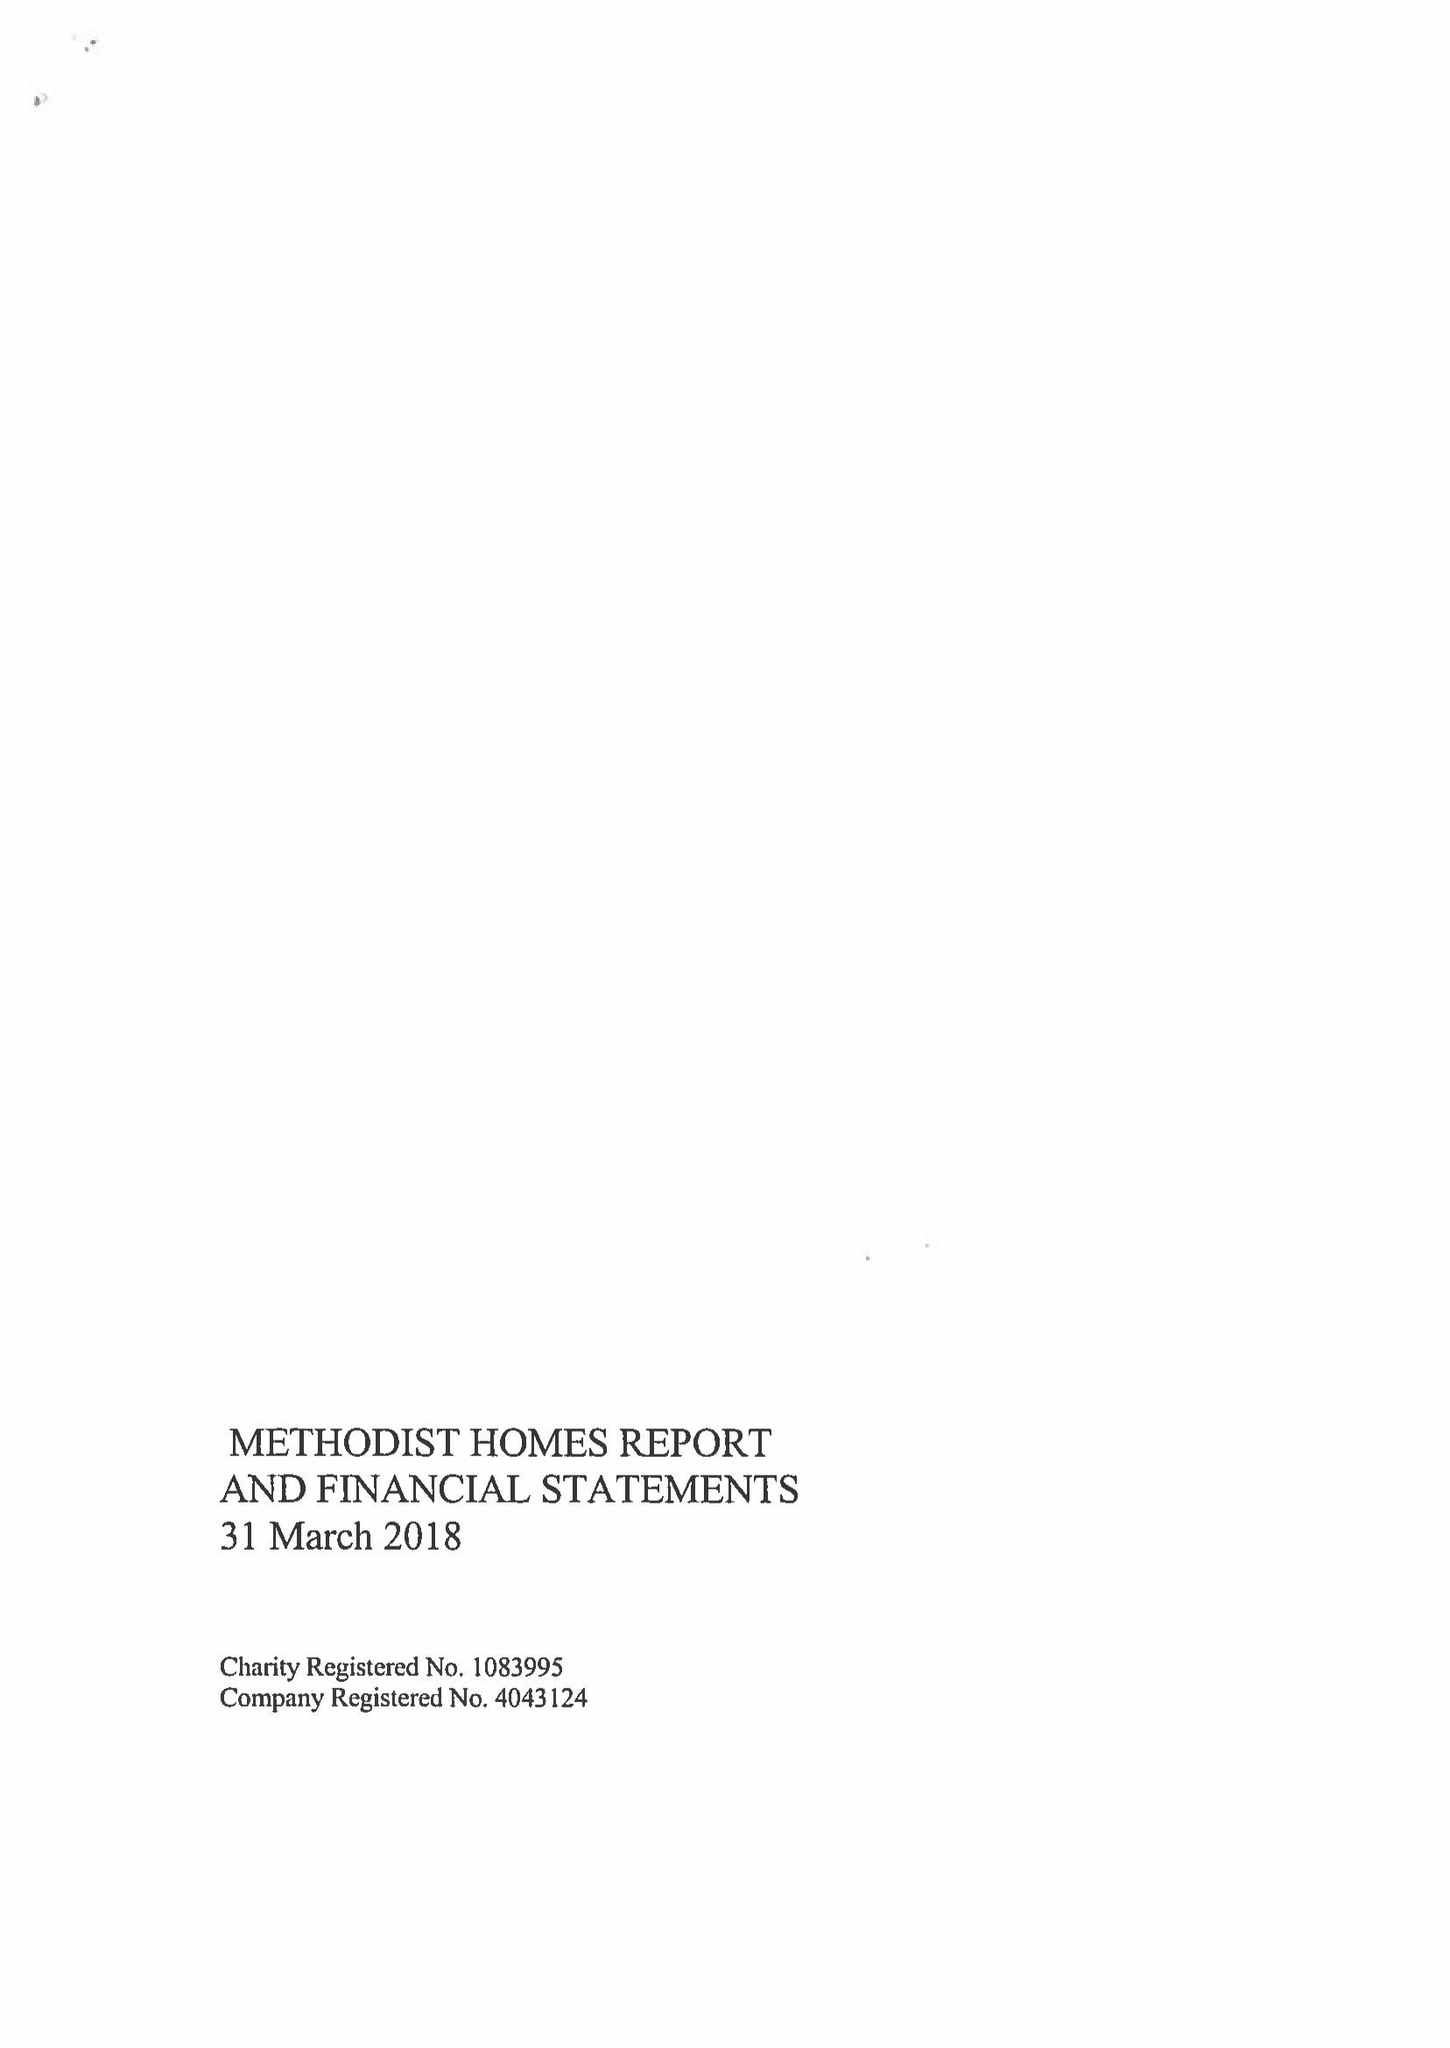What is the value for the address__street_line?
Answer the question using a single word or phrase. STUART STREET 